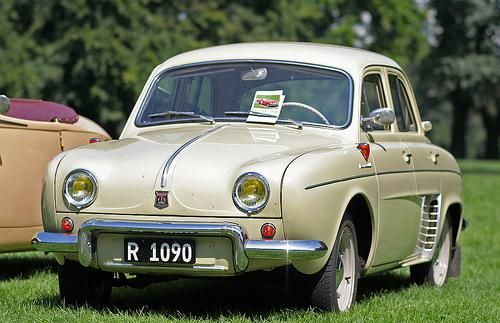What is the style of the car in this picture? The car in the image is designed in a vintage or classic style, indicative of the mid-20th-century automobile design. 